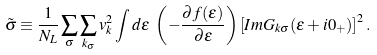<formula> <loc_0><loc_0><loc_500><loc_500>\tilde { \sigma } & \equiv \frac { 1 } { N _ { L } } \sum _ { \sigma } \sum _ { { k } _ { \sigma } } v _ { k } ^ { 2 } \int d \varepsilon \ \left ( - \frac { \partial f ( \varepsilon ) } { \partial \varepsilon } \right ) \left [ I m G _ { { k } \sigma } ( \varepsilon + i 0 _ { + } ) \right ] ^ { 2 } .</formula> 